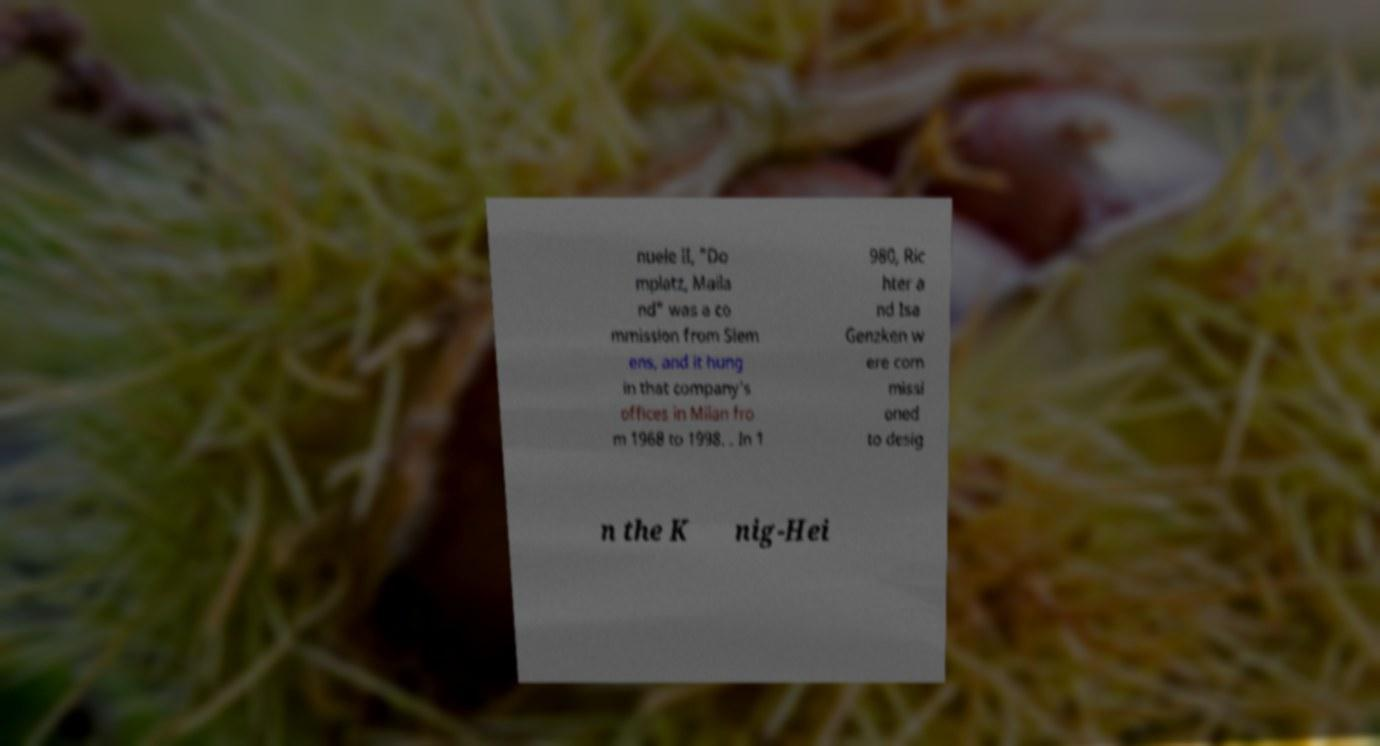Please read and relay the text visible in this image. What does it say? nuele II, "Do mplatz, Maila nd" was a co mmission from Siem ens, and it hung in that company's offices in Milan fro m 1968 to 1998. . In 1 980, Ric hter a nd Isa Genzken w ere com missi oned to desig n the K nig-Hei 